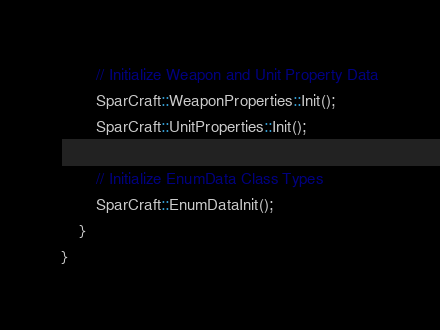Convert code to text. <code><loc_0><loc_0><loc_500><loc_500><_C++_>        // Initialize Weapon and Unit Property Data
        SparCraft::WeaponProperties::Init();
	    SparCraft::UnitProperties::Init();
    
        // Initialize EnumData Class Types
        SparCraft::EnumDataInit();
    }
}</code> 